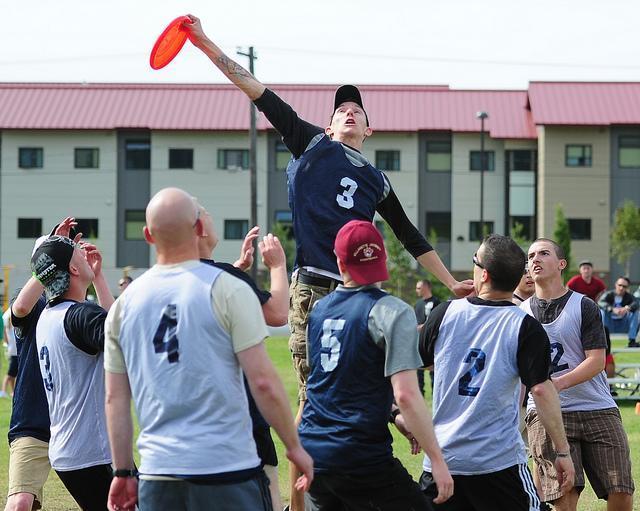How many are wearing glasses?
Give a very brief answer. 1. How many people can you see?
Give a very brief answer. 8. 